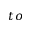<formula> <loc_0><loc_0><loc_500><loc_500>t o</formula> 